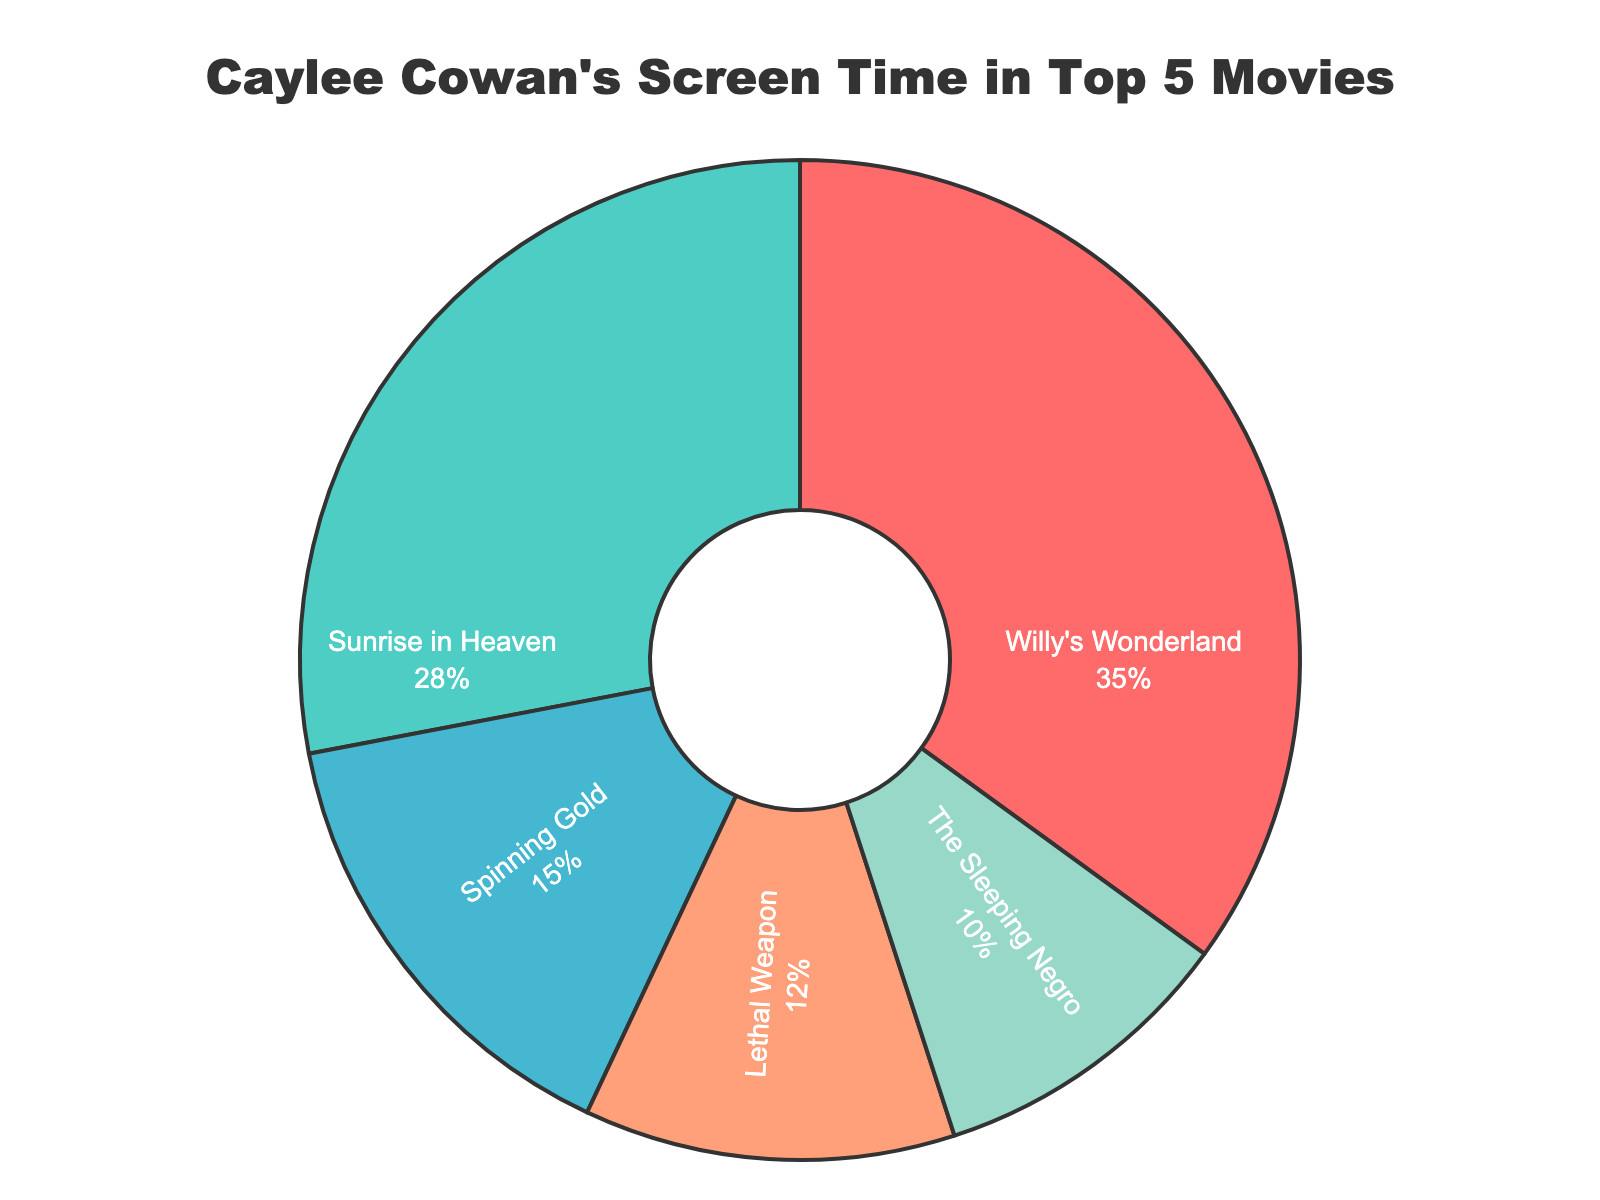What percentage of screen time does "Willy's Wonderland" have? Refer to the pie chart and look at the label for "Willy's Wonderland". The percentage displayed next to it is 35%.
Answer: 35% Which movie has the least screen time? Look for the smallest piece of the pie chart and read the label attached to it. "The Sleeping Negro" is the smallest segment, representing 10% of the screen time.
Answer: The Sleeping Negro How much more screen time does "Sunrise in Heaven" have compared to "Spinning Gold"? Identify the percentages for both movies from the pie chart: "Sunrise in Heaven" at 28% and "Spinning Gold" at 15%. Subtract 15% from 28%. 28% - 15% = 13%.
Answer: 13% What is the total screen time percentage for “Lethal Weapon” and “The Sleeping Negro”? Locate the percentages for "Lethal Weapon" (12%) and "The Sleeping Negro" (10%) in the pie chart. Add the two percentages together: 12% + 10% = 22%.
Answer: 22% Which movie has the closest screen time percentage to "Sunrise in Heaven"? Check the pie chart to compare percentages. "Willy's Wonderland" has the nearest percentage to "Sunrise in Heaven", with 35% compared to 28%. Other movies have significantly lower percentages.
Answer: Willy's Wonderland Rank Caylee Cowan's movies from most to least screen time. Examine the pie chart for each segment's percentage. The ranking in descending order is: 1. Willy's Wonderland (35%), 2. Sunrise in Heaven (28%), 3. Spinning Gold (15%), 4. Lethal Weapon (12%), 5. The Sleeping Negro (10%).
Answer: Willy's Wonderland, Sunrise in Heaven, Spinning Gold, Lethal Weapon, The Sleeping Negro What is the average screen time percentage for Caylee Cowan's top 5 movies? Sum the percentages from the pie chart for all movies: 35% + 28% + 15% + 12% + 10% = 100%. Divide by the number of movies, which is 5. 100% / 5 = 20%.
Answer: 20% Is the total screen time percentage of "Willy's Wonderland" and "Lethal Weapon" greater than "Sunrise in Heaven" and "Spinning Gold" combined? Sum the percentages of "Willy's Wonderland" (35%) and "Lethal Weapon" (12%): 35% + 12% = 47%. Sum the percentages of "Sunrise in Heaven" (28%) and "Spinning Gold" (15%): 28% + 15% = 43%. Compare the sums: 47% is greater than 43%, so yes.
Answer: Yes What is the difference between the highest and the lowest screen time percentages? Identify the highest percentage from "Willy's Wonderland" (35%) and the lowest from "The Sleeping Negro" (10%). Subtract the lowest from the highest: 35% - 10% = 25%.
Answer: 25% What percent of the screen time is captured by the movies that have more than 20% screen time? Identify the movies with more than 20% screen time from the pie chart: "Willy's Wonderland" (35%) and "Sunrise in Heaven" (28%). Sum the percentages: 35% + 28% = 63%.
Answer: 63% 